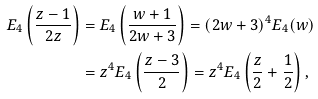Convert formula to latex. <formula><loc_0><loc_0><loc_500><loc_500>E _ { 4 } \left ( \frac { z - 1 } { 2 z } \right ) & = E _ { 4 } \left ( \frac { w + 1 } { 2 w + 3 } \right ) = ( 2 w + 3 ) ^ { 4 } E _ { 4 } ( w ) \\ & = z ^ { 4 } E _ { 4 } \left ( \frac { z - 3 } { 2 } \right ) = z ^ { 4 } E _ { 4 } \left ( \frac { z } { 2 } + \frac { 1 } { 2 } \right ) ,</formula> 